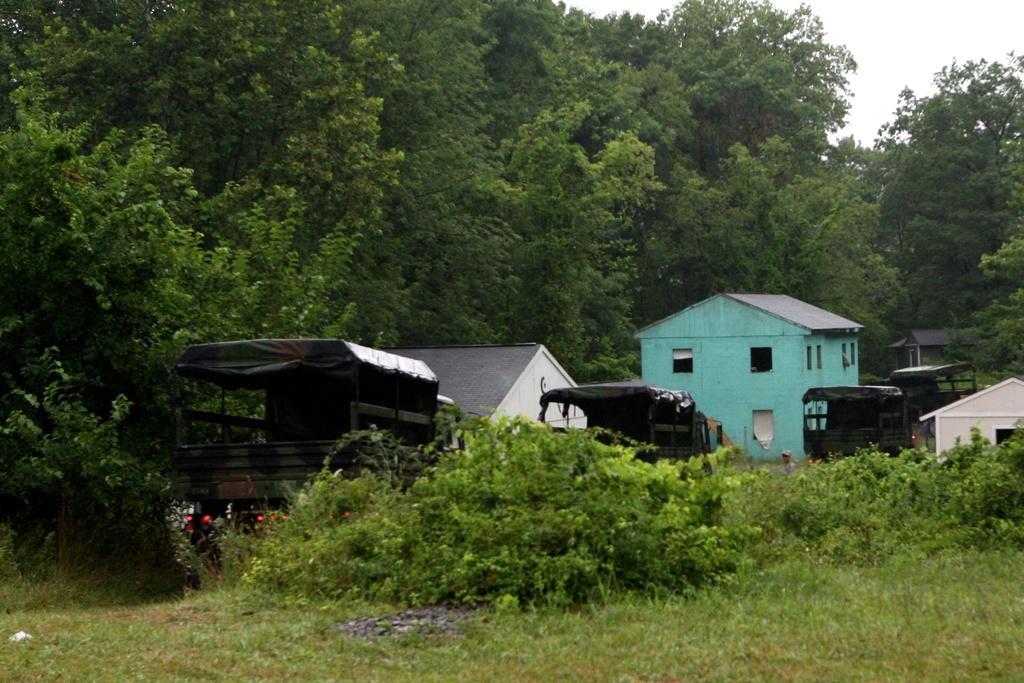In one or two sentences, can you explain what this image depicts? In this image, we can see vehicles, sheds and a building. In the background, there are trees and we can see some plants. At the bottom, there is ground and at the top, there is sky. 